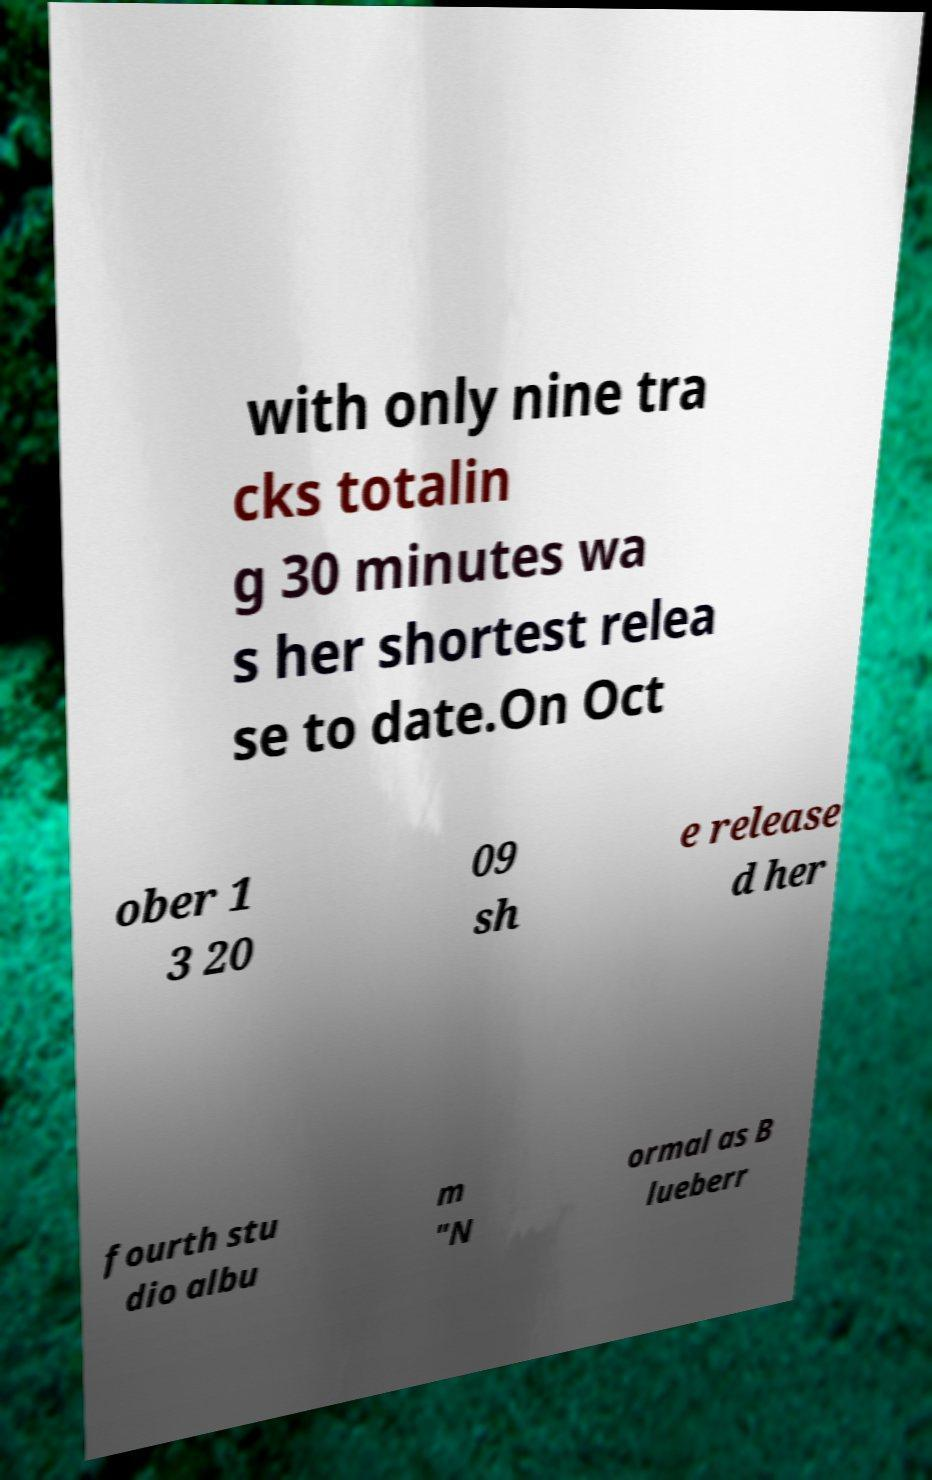Can you read and provide the text displayed in the image?This photo seems to have some interesting text. Can you extract and type it out for me? with only nine tra cks totalin g 30 minutes wa s her shortest relea se to date.On Oct ober 1 3 20 09 sh e release d her fourth stu dio albu m "N ormal as B lueberr 